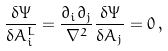Convert formula to latex. <formula><loc_0><loc_0><loc_500><loc_500>\frac { \delta \Psi } { \delta A ^ { L } _ { i } } = \frac { \partial _ { i } \partial _ { j } } { \nabla ^ { 2 } } \frac { \delta \Psi } { \delta A _ { j } } = 0 \, ,</formula> 